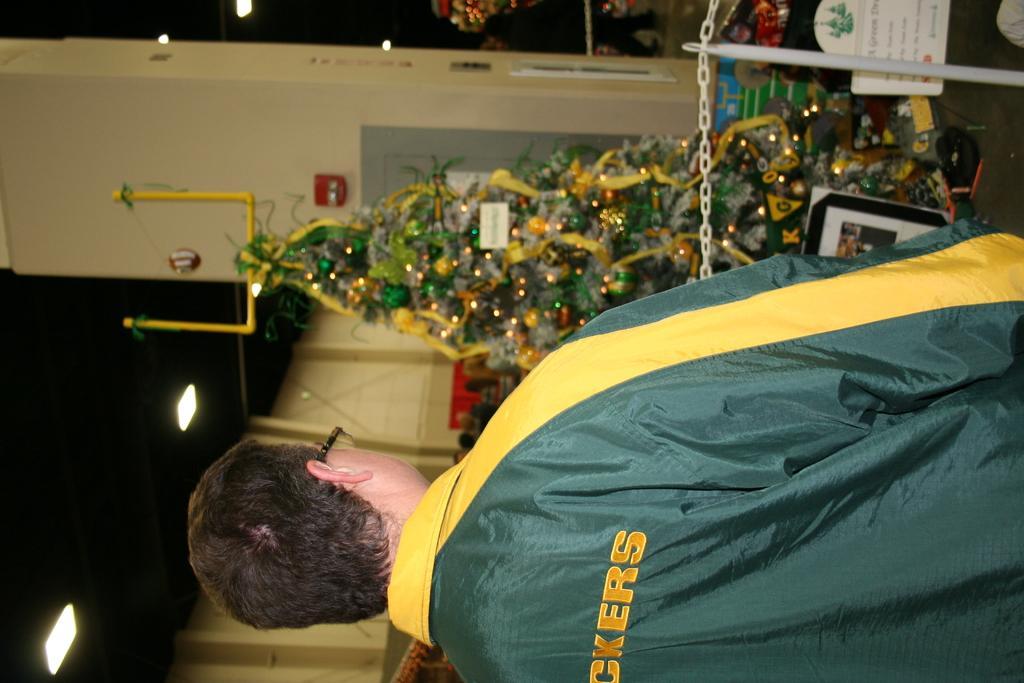In one or two sentences, can you explain what this image depicts? In this image at the bottom there is a man, he wears a jacket. In the middle there are posters, Christmas tree, decorations, lights, chain, pole and wall. 